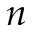Convert formula to latex. <formula><loc_0><loc_0><loc_500><loc_500>n</formula> 